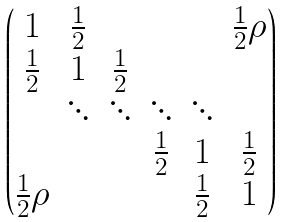<formula> <loc_0><loc_0><loc_500><loc_500>\begin{pmatrix} 1 & \frac { 1 } { 2 } & & & & \frac { 1 } { 2 } \rho \\ \frac { 1 } { 2 } & 1 & \frac { 1 } { 2 } & & & \\ & \ddots & \ddots & \ddots & \ddots \\ & & & \frac { 1 } { 2 } & 1 & \frac { 1 } { 2 } \\ \frac { 1 } { 2 } \rho & & & & \frac { 1 } { 2 } & 1 \end{pmatrix}</formula> 